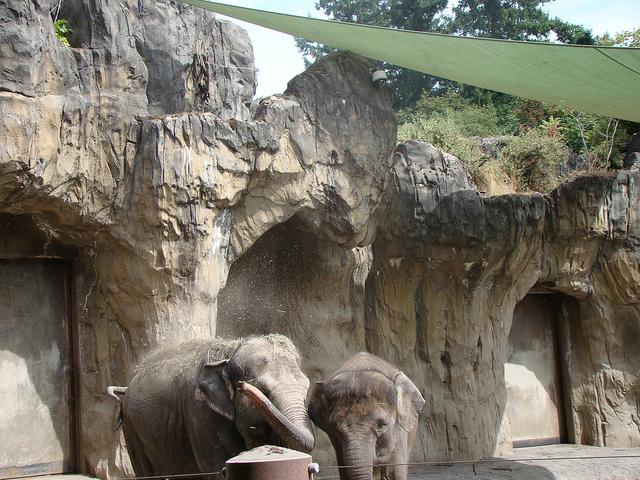Are the elephants in their natural habitat?
Quick response, please. No. Are the elephants in the shade?
Concise answer only. No. Are the elephants in a enclosure?
Concise answer only. Yes. 